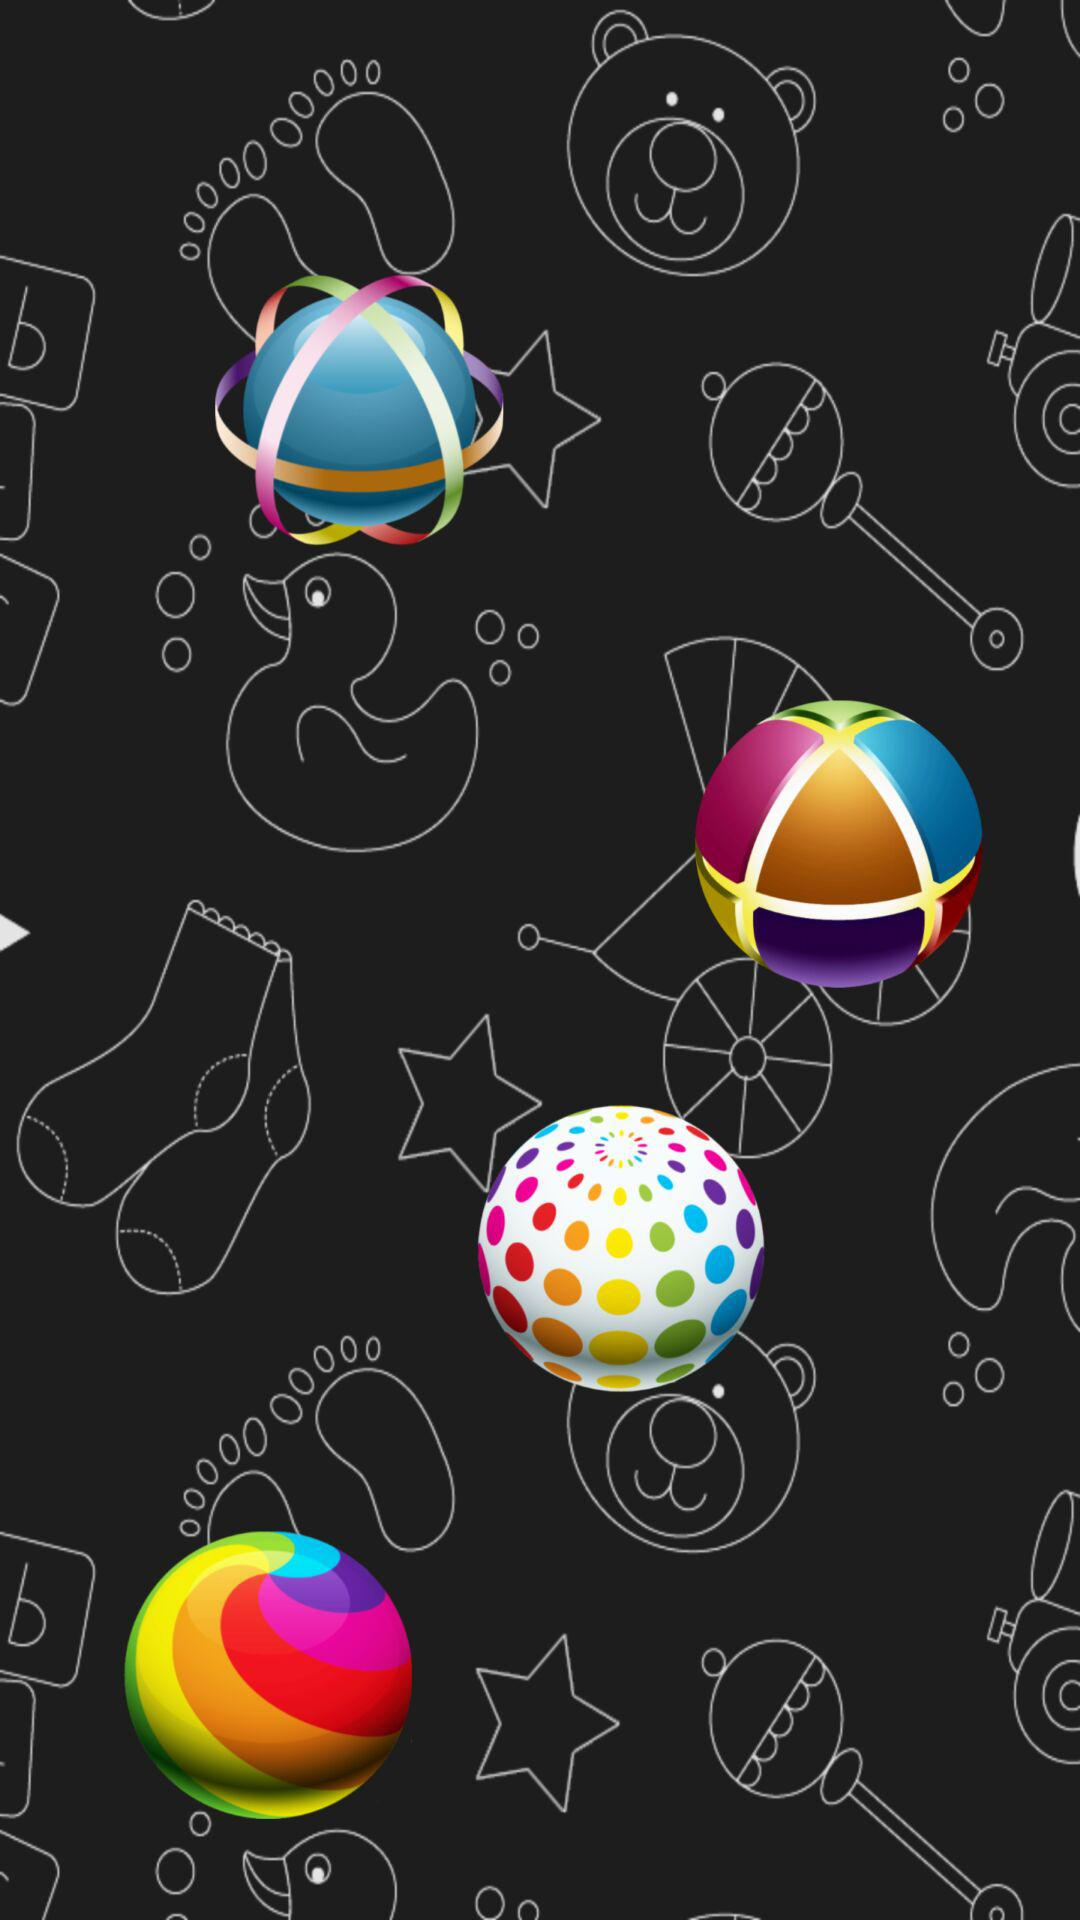How many toys are on the blackboard?
Answer the question using a single word or phrase. 4 